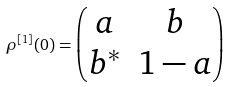Convert formula to latex. <formula><loc_0><loc_0><loc_500><loc_500>\rho ^ { [ 1 ] } ( 0 ) = \begin{pmatrix} a & b \\ b ^ { * } & 1 - a \end{pmatrix}</formula> 